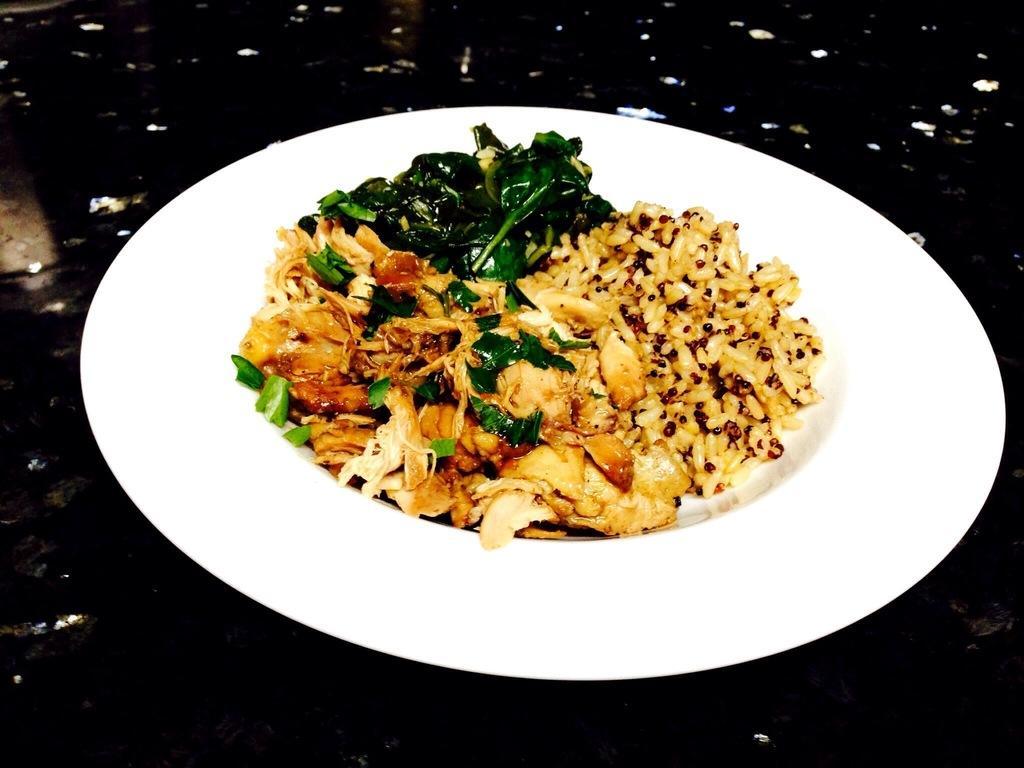In one or two sentences, can you explain what this image depicts? There is a food item kept in a white color plate as we can see in the middle of this image. 